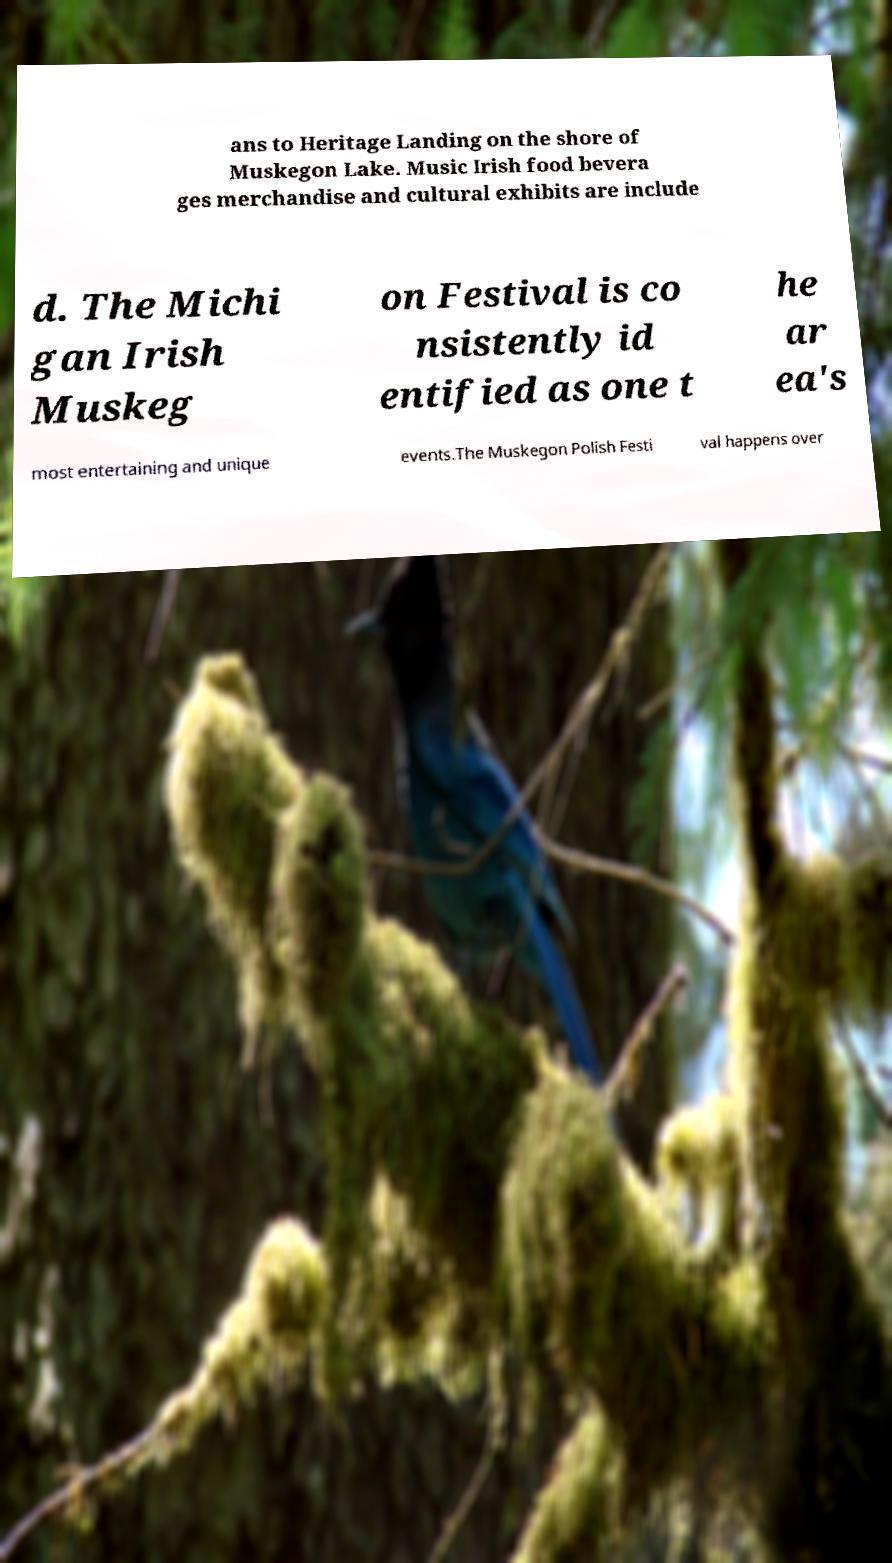I need the written content from this picture converted into text. Can you do that? ans to Heritage Landing on the shore of Muskegon Lake. Music Irish food bevera ges merchandise and cultural exhibits are include d. The Michi gan Irish Muskeg on Festival is co nsistently id entified as one t he ar ea's most entertaining and unique events.The Muskegon Polish Festi val happens over 